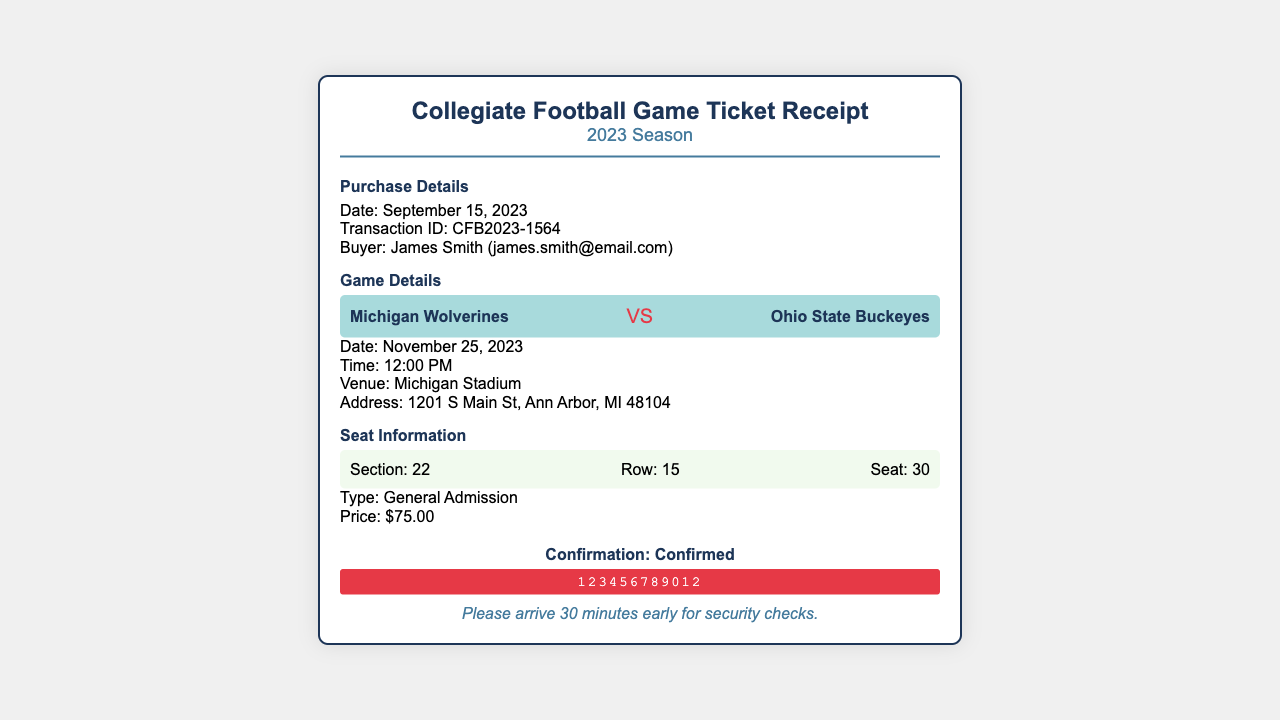What is the date of the game? The date of the game is mentioned in the game details section of the document.
Answer: November 25, 2023 What is the price of the ticket? The ticket price is listed in the seat information section of the document.
Answer: $75.00 What is the transaction ID? The transaction ID is provided in the purchase details section of the document.
Answer: CFB2023-1564 Who is the buyer? The buyer's name and email are specified in the purchase details section of the document.
Answer: James Smith (james.smith@email.com) What section is the seat located in? The seat section is found in the seat information section of the document.
Answer: 22 What time does the game start? The start time of the game is indicated in the game details section of the document.
Answer: 12:00 PM What type of admission is the ticket? The type of admission is stated in the seat information section of the document.
Answer: General Admission What is the venue of the game? The venue where the game will be held is specified in the game details section of the document.
Answer: Michigan Stadium What should you do before arriving? A note regarding arrival is mentioned in the confirmation section of the document.
Answer: Please arrive 30 minutes early for security checks 